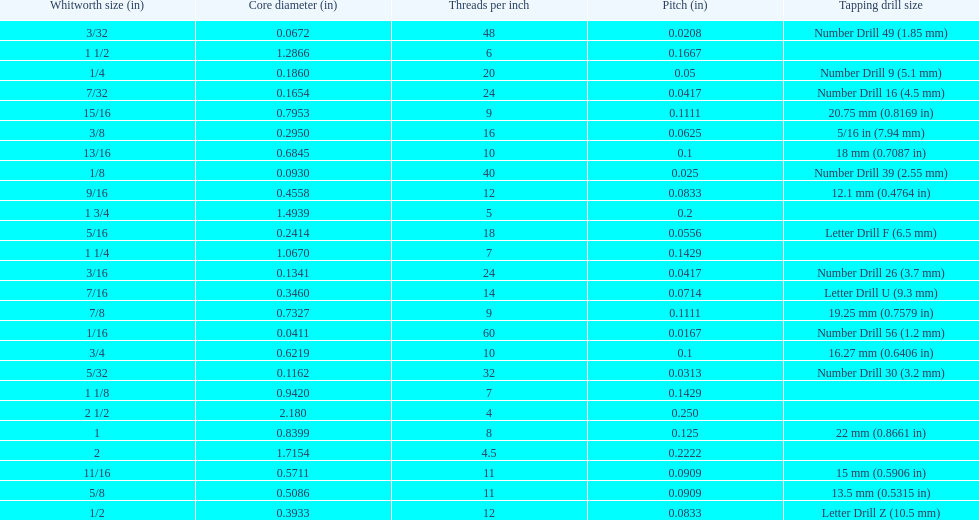What is the least core diameter (in)? 0.0411. 